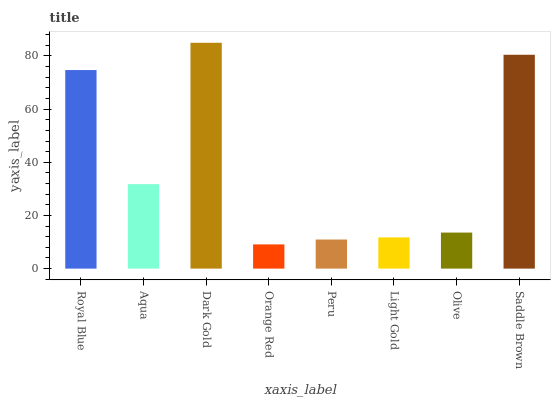Is Orange Red the minimum?
Answer yes or no. Yes. Is Dark Gold the maximum?
Answer yes or no. Yes. Is Aqua the minimum?
Answer yes or no. No. Is Aqua the maximum?
Answer yes or no. No. Is Royal Blue greater than Aqua?
Answer yes or no. Yes. Is Aqua less than Royal Blue?
Answer yes or no. Yes. Is Aqua greater than Royal Blue?
Answer yes or no. No. Is Royal Blue less than Aqua?
Answer yes or no. No. Is Aqua the high median?
Answer yes or no. Yes. Is Olive the low median?
Answer yes or no. Yes. Is Saddle Brown the high median?
Answer yes or no. No. Is Aqua the low median?
Answer yes or no. No. 